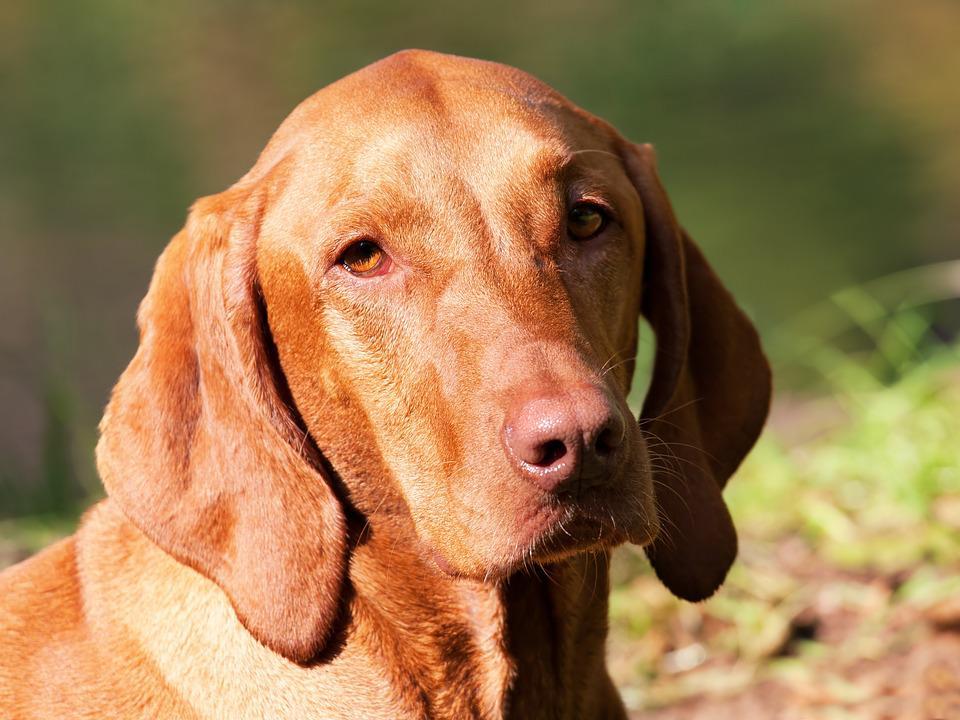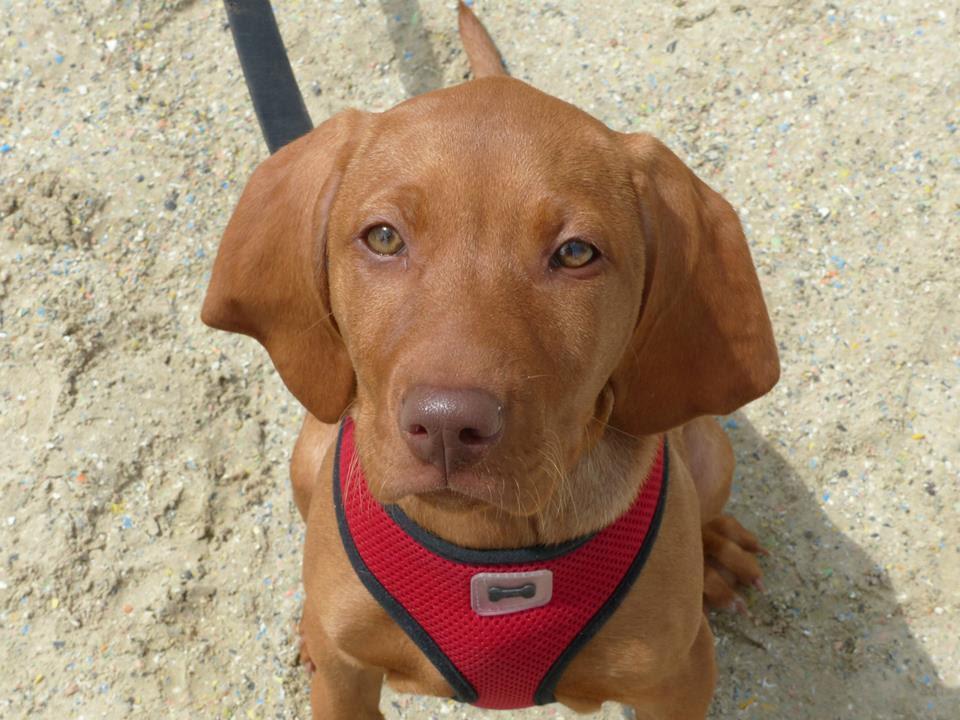The first image is the image on the left, the second image is the image on the right. For the images shown, is this caption "The dog on the left is wearing a brightly colored, clearly visible collar, while the dog on the right is seemingly not wearing a collar or anything else around it's neck." true? Answer yes or no. No. The first image is the image on the left, the second image is the image on the right. For the images displayed, is the sentence "The left image features a close-mouthed dog in a collar gazing up and to the left, and the right image features a puppy with a wrinkly mouth." factually correct? Answer yes or no. No. 